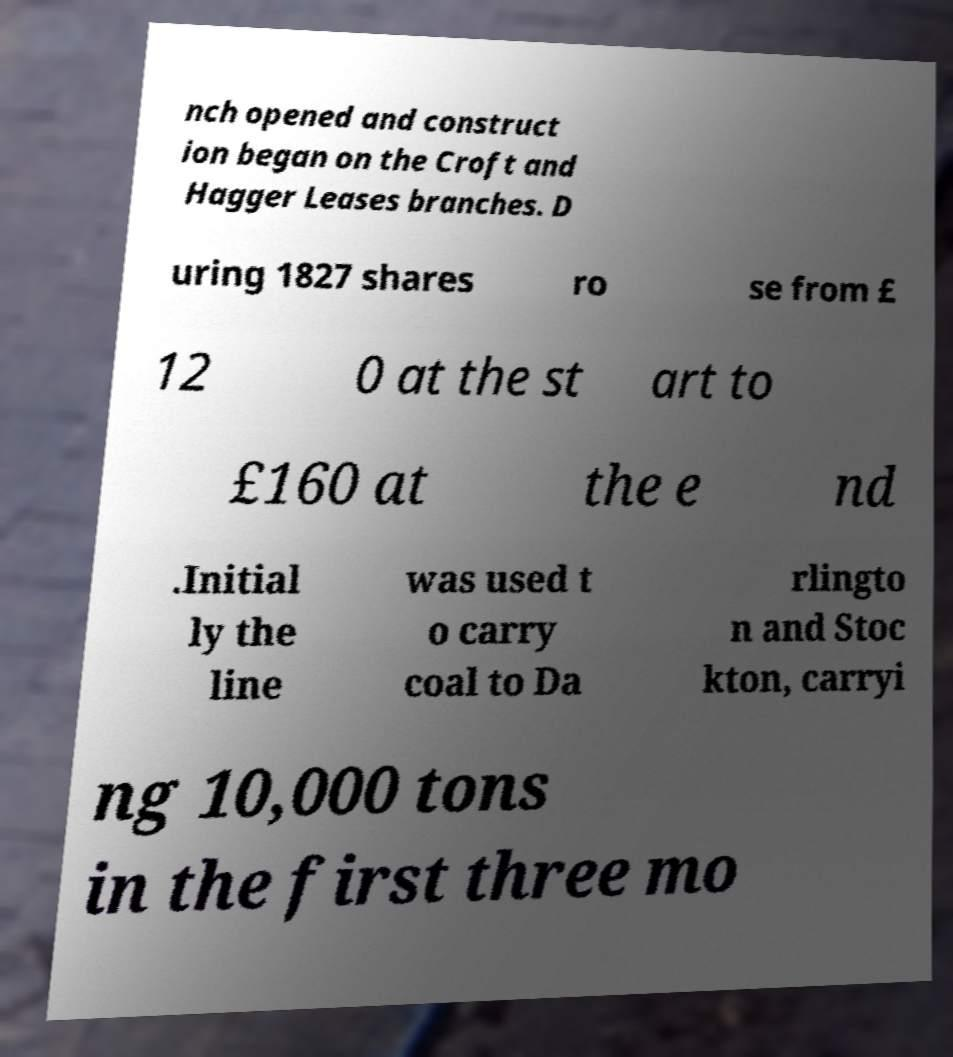Can you accurately transcribe the text from the provided image for me? nch opened and construct ion began on the Croft and Hagger Leases branches. D uring 1827 shares ro se from £ 12 0 at the st art to £160 at the e nd .Initial ly the line was used t o carry coal to Da rlingto n and Stoc kton, carryi ng 10,000 tons in the first three mo 